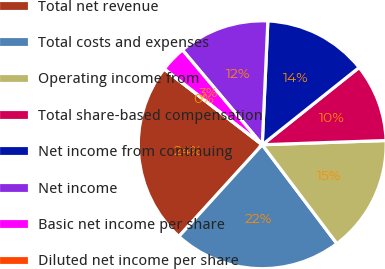Convert chart. <chart><loc_0><loc_0><loc_500><loc_500><pie_chart><fcel>Total net revenue<fcel>Total costs and expenses<fcel>Operating income from<fcel>Total share-based compensation<fcel>Net income from continuing<fcel>Net income<fcel>Basic net income per share<fcel>Diluted net income per share<nl><fcel>23.73%<fcel>22.03%<fcel>15.25%<fcel>10.17%<fcel>13.56%<fcel>11.86%<fcel>3.39%<fcel>0.0%<nl></chart> 